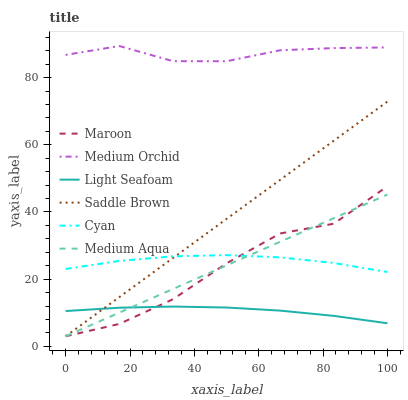Does Light Seafoam have the minimum area under the curve?
Answer yes or no. Yes. Does Medium Orchid have the maximum area under the curve?
Answer yes or no. Yes. Does Maroon have the minimum area under the curve?
Answer yes or no. No. Does Maroon have the maximum area under the curve?
Answer yes or no. No. Is Medium Aqua the smoothest?
Answer yes or no. Yes. Is Maroon the roughest?
Answer yes or no. Yes. Is Maroon the smoothest?
Answer yes or no. No. Is Medium Aqua the roughest?
Answer yes or no. No. Does Maroon have the lowest value?
Answer yes or no. Yes. Does Cyan have the lowest value?
Answer yes or no. No. Does Medium Orchid have the highest value?
Answer yes or no. Yes. Does Maroon have the highest value?
Answer yes or no. No. Is Cyan less than Medium Orchid?
Answer yes or no. Yes. Is Cyan greater than Light Seafoam?
Answer yes or no. Yes. Does Medium Aqua intersect Light Seafoam?
Answer yes or no. Yes. Is Medium Aqua less than Light Seafoam?
Answer yes or no. No. Is Medium Aqua greater than Light Seafoam?
Answer yes or no. No. Does Cyan intersect Medium Orchid?
Answer yes or no. No. 